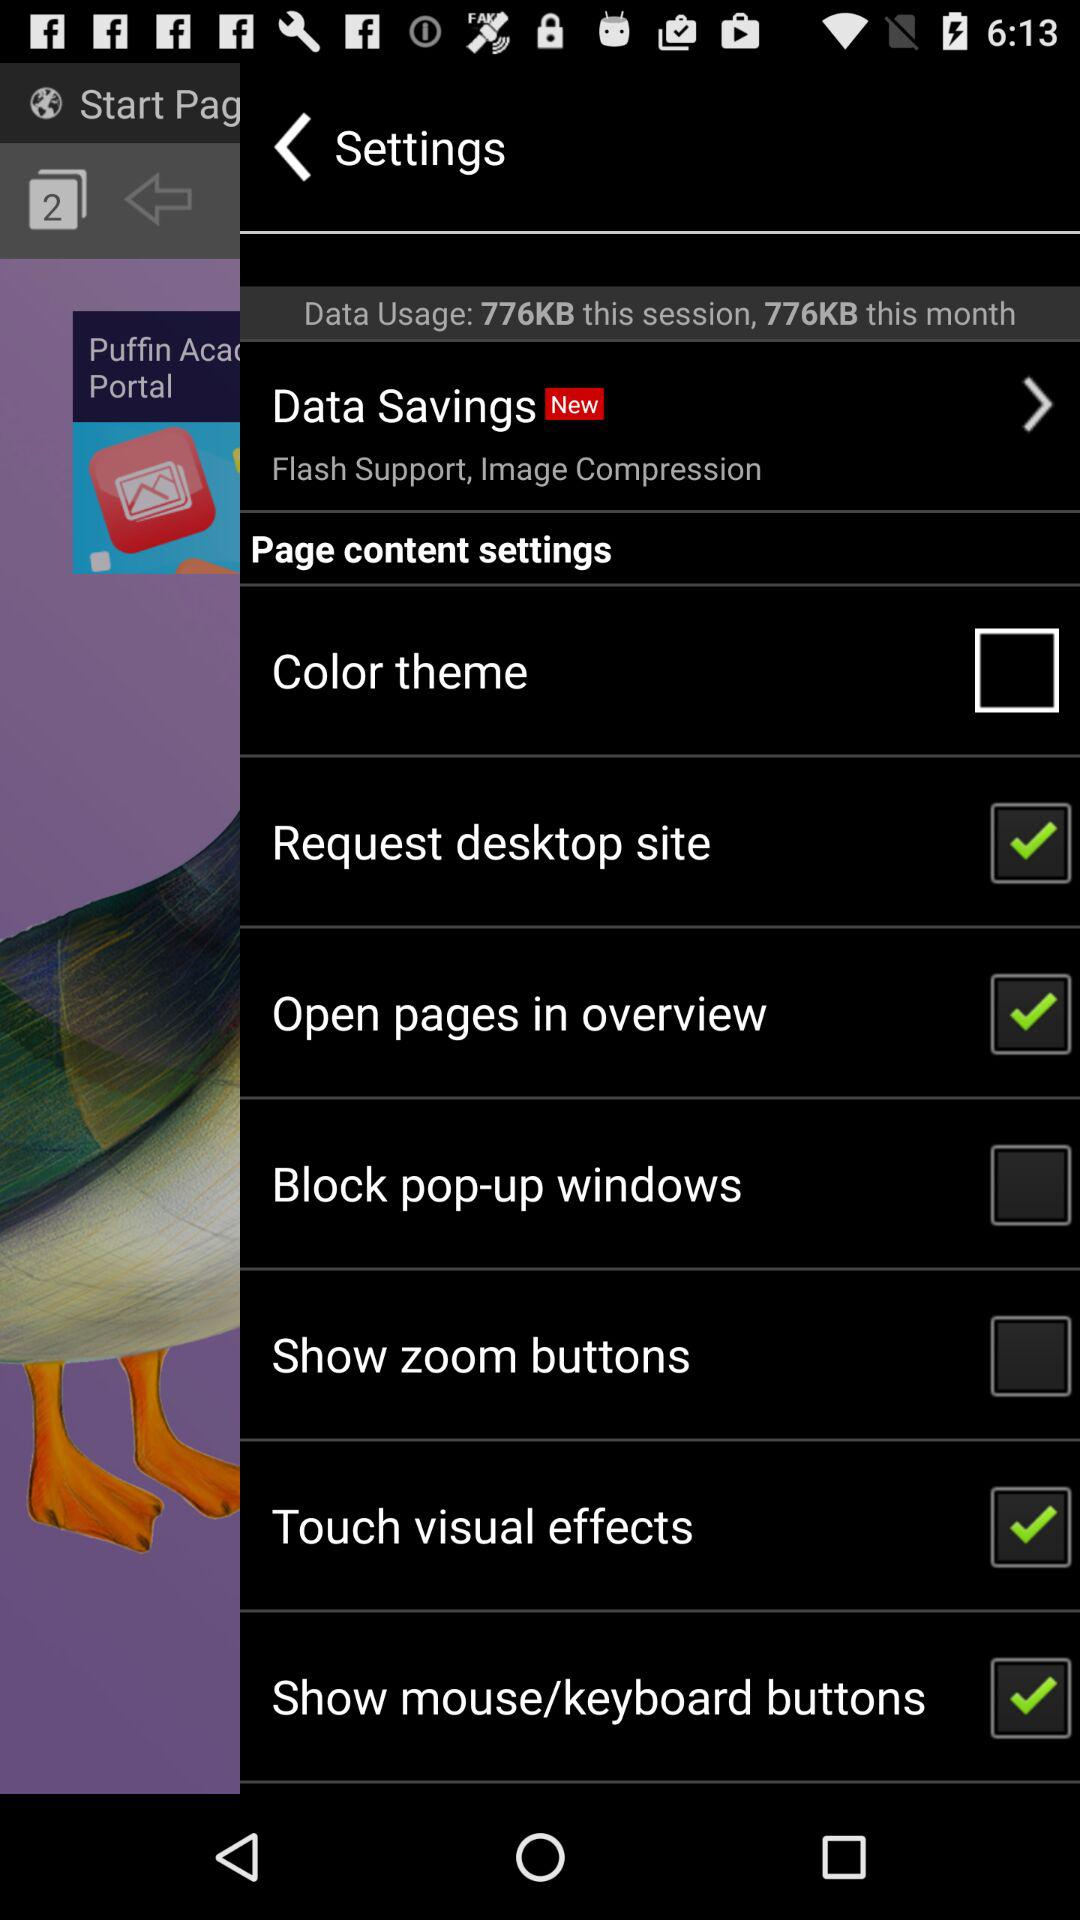What is the data usage for this session? The data usage for this session is 776 KB. 